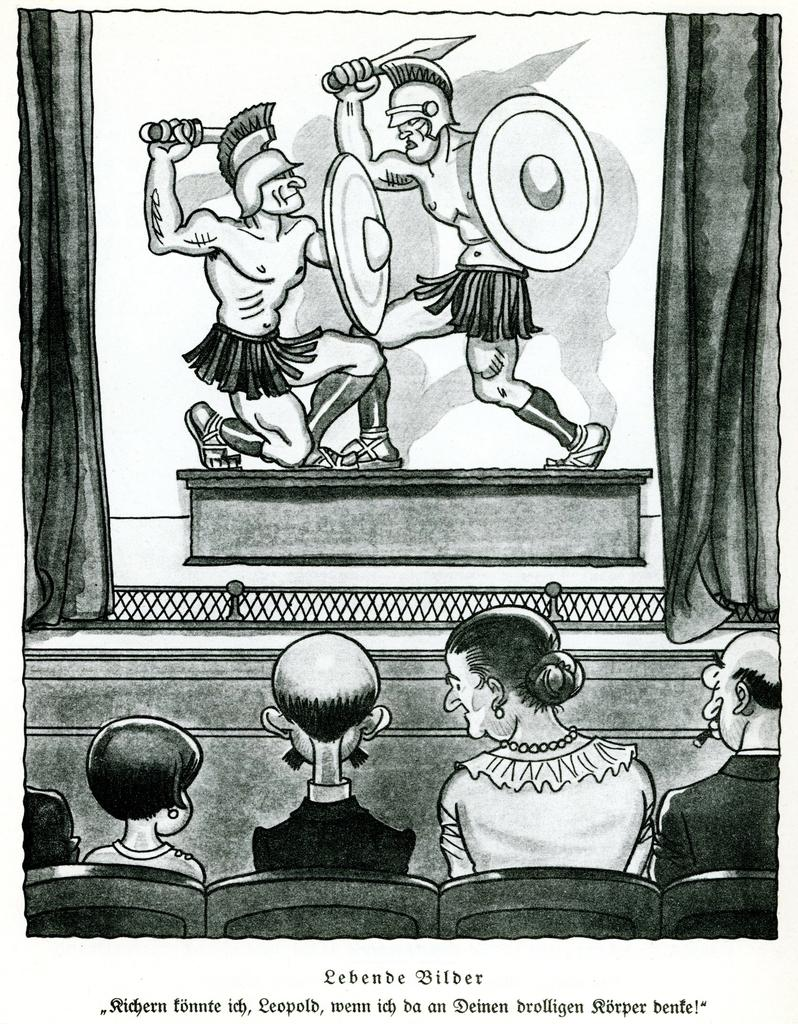What is the color scheme of the image? The image is black and white. What is depicted in the sketch? There is a sketch of people sitting on chairs and two persons fighting with swords. What type of advice can be seen written on the edge of the sketch? There is no advice written on the edge of the sketch, as the image is a black and white sketch with no text present. 